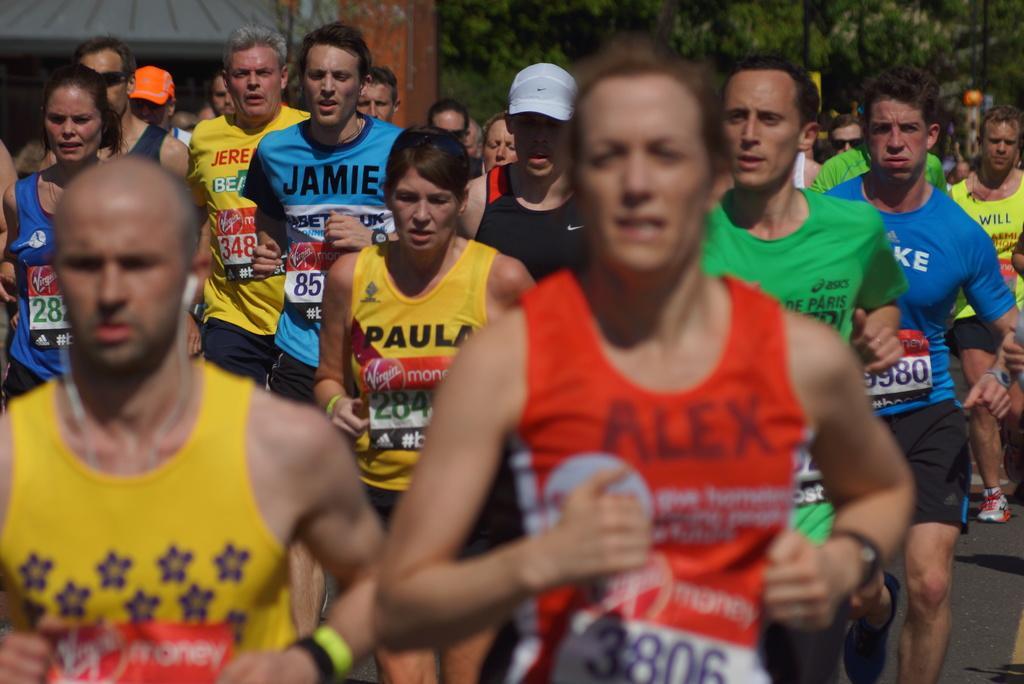Please provide a concise description of this image. In this image there are people running on the road. Middle of the image there is a person wearing a cap. Behind the people there are poles. Left side there is a pillar. Left top there is a house. Background there are trees. 